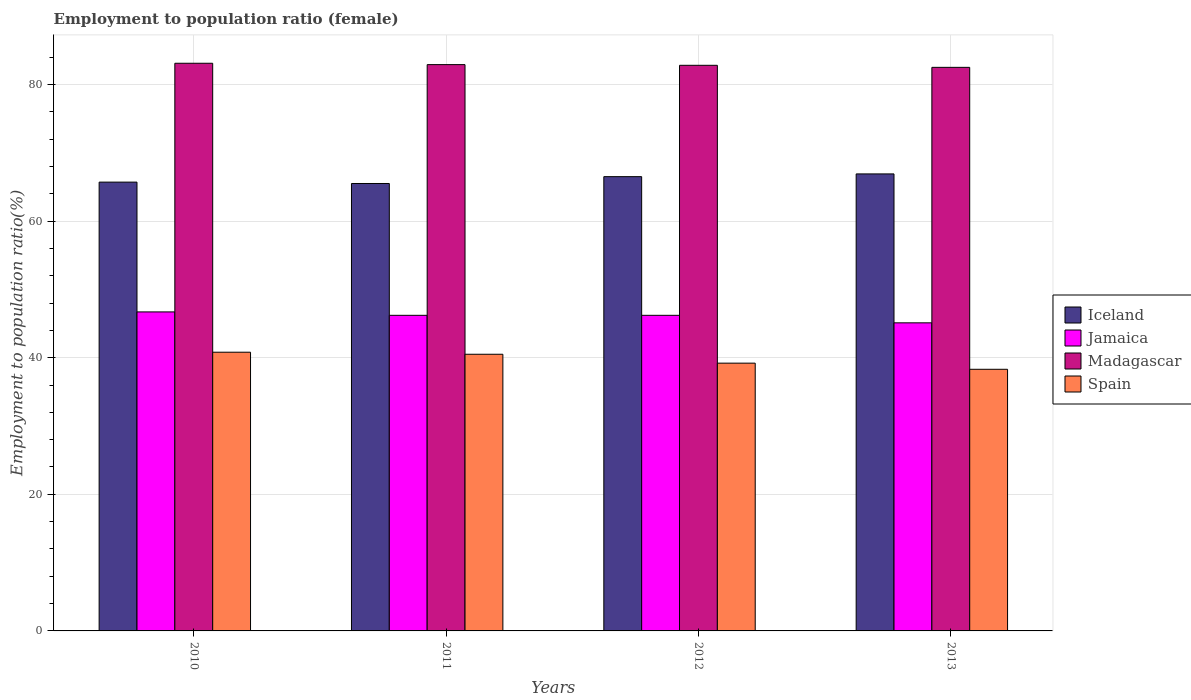In how many cases, is the number of bars for a given year not equal to the number of legend labels?
Give a very brief answer. 0. What is the employment to population ratio in Iceland in 2010?
Keep it short and to the point. 65.7. Across all years, what is the maximum employment to population ratio in Spain?
Your answer should be very brief. 40.8. Across all years, what is the minimum employment to population ratio in Spain?
Provide a succinct answer. 38.3. In which year was the employment to population ratio in Iceland minimum?
Your response must be concise. 2011. What is the total employment to population ratio in Iceland in the graph?
Provide a succinct answer. 264.6. What is the difference between the employment to population ratio in Iceland in 2012 and that in 2013?
Give a very brief answer. -0.4. What is the difference between the employment to population ratio in Iceland in 2011 and the employment to population ratio in Jamaica in 2013?
Provide a short and direct response. 20.4. What is the average employment to population ratio in Madagascar per year?
Your answer should be very brief. 82.83. In the year 2012, what is the difference between the employment to population ratio in Jamaica and employment to population ratio in Iceland?
Your answer should be compact. -20.3. In how many years, is the employment to population ratio in Jamaica greater than 16 %?
Offer a very short reply. 4. What is the ratio of the employment to population ratio in Madagascar in 2010 to that in 2013?
Offer a very short reply. 1.01. What is the difference between the highest and the second highest employment to population ratio in Spain?
Offer a very short reply. 0.3. What is the difference between the highest and the lowest employment to population ratio in Madagascar?
Make the answer very short. 0.6. In how many years, is the employment to population ratio in Spain greater than the average employment to population ratio in Spain taken over all years?
Keep it short and to the point. 2. Is it the case that in every year, the sum of the employment to population ratio in Madagascar and employment to population ratio in Spain is greater than the sum of employment to population ratio in Iceland and employment to population ratio in Jamaica?
Offer a terse response. No. What does the 2nd bar from the left in 2012 represents?
Provide a succinct answer. Jamaica. What does the 4th bar from the right in 2012 represents?
Provide a succinct answer. Iceland. Is it the case that in every year, the sum of the employment to population ratio in Madagascar and employment to population ratio in Jamaica is greater than the employment to population ratio in Spain?
Provide a short and direct response. Yes. Are all the bars in the graph horizontal?
Offer a terse response. No. How many years are there in the graph?
Your answer should be compact. 4. Are the values on the major ticks of Y-axis written in scientific E-notation?
Keep it short and to the point. No. Does the graph contain any zero values?
Your response must be concise. No. How many legend labels are there?
Make the answer very short. 4. What is the title of the graph?
Offer a very short reply. Employment to population ratio (female). Does "Venezuela" appear as one of the legend labels in the graph?
Provide a short and direct response. No. What is the label or title of the X-axis?
Offer a terse response. Years. What is the label or title of the Y-axis?
Keep it short and to the point. Employment to population ratio(%). What is the Employment to population ratio(%) of Iceland in 2010?
Provide a succinct answer. 65.7. What is the Employment to population ratio(%) of Jamaica in 2010?
Keep it short and to the point. 46.7. What is the Employment to population ratio(%) in Madagascar in 2010?
Provide a succinct answer. 83.1. What is the Employment to population ratio(%) in Spain in 2010?
Your answer should be very brief. 40.8. What is the Employment to population ratio(%) of Iceland in 2011?
Offer a very short reply. 65.5. What is the Employment to population ratio(%) of Jamaica in 2011?
Your response must be concise. 46.2. What is the Employment to population ratio(%) in Madagascar in 2011?
Make the answer very short. 82.9. What is the Employment to population ratio(%) of Spain in 2011?
Provide a short and direct response. 40.5. What is the Employment to population ratio(%) of Iceland in 2012?
Provide a short and direct response. 66.5. What is the Employment to population ratio(%) in Jamaica in 2012?
Provide a succinct answer. 46.2. What is the Employment to population ratio(%) in Madagascar in 2012?
Your answer should be very brief. 82.8. What is the Employment to population ratio(%) in Spain in 2012?
Keep it short and to the point. 39.2. What is the Employment to population ratio(%) of Iceland in 2013?
Your answer should be compact. 66.9. What is the Employment to population ratio(%) in Jamaica in 2013?
Offer a terse response. 45.1. What is the Employment to population ratio(%) of Madagascar in 2013?
Provide a succinct answer. 82.5. What is the Employment to population ratio(%) of Spain in 2013?
Offer a very short reply. 38.3. Across all years, what is the maximum Employment to population ratio(%) in Iceland?
Offer a very short reply. 66.9. Across all years, what is the maximum Employment to population ratio(%) in Jamaica?
Offer a terse response. 46.7. Across all years, what is the maximum Employment to population ratio(%) of Madagascar?
Your answer should be compact. 83.1. Across all years, what is the maximum Employment to population ratio(%) in Spain?
Your answer should be compact. 40.8. Across all years, what is the minimum Employment to population ratio(%) of Iceland?
Offer a terse response. 65.5. Across all years, what is the minimum Employment to population ratio(%) in Jamaica?
Your response must be concise. 45.1. Across all years, what is the minimum Employment to population ratio(%) in Madagascar?
Your response must be concise. 82.5. Across all years, what is the minimum Employment to population ratio(%) of Spain?
Ensure brevity in your answer.  38.3. What is the total Employment to population ratio(%) of Iceland in the graph?
Provide a succinct answer. 264.6. What is the total Employment to population ratio(%) of Jamaica in the graph?
Provide a short and direct response. 184.2. What is the total Employment to population ratio(%) of Madagascar in the graph?
Provide a short and direct response. 331.3. What is the total Employment to population ratio(%) in Spain in the graph?
Provide a short and direct response. 158.8. What is the difference between the Employment to population ratio(%) in Iceland in 2010 and that in 2011?
Provide a succinct answer. 0.2. What is the difference between the Employment to population ratio(%) of Madagascar in 2010 and that in 2011?
Provide a short and direct response. 0.2. What is the difference between the Employment to population ratio(%) in Spain in 2010 and that in 2011?
Ensure brevity in your answer.  0.3. What is the difference between the Employment to population ratio(%) in Jamaica in 2010 and that in 2012?
Your answer should be compact. 0.5. What is the difference between the Employment to population ratio(%) in Madagascar in 2010 and that in 2012?
Your answer should be very brief. 0.3. What is the difference between the Employment to population ratio(%) of Iceland in 2010 and that in 2013?
Ensure brevity in your answer.  -1.2. What is the difference between the Employment to population ratio(%) of Jamaica in 2010 and that in 2013?
Provide a short and direct response. 1.6. What is the difference between the Employment to population ratio(%) of Madagascar in 2010 and that in 2013?
Provide a succinct answer. 0.6. What is the difference between the Employment to population ratio(%) of Jamaica in 2011 and that in 2012?
Offer a very short reply. 0. What is the difference between the Employment to population ratio(%) of Spain in 2011 and that in 2012?
Make the answer very short. 1.3. What is the difference between the Employment to population ratio(%) in Jamaica in 2012 and that in 2013?
Your answer should be very brief. 1.1. What is the difference between the Employment to population ratio(%) of Spain in 2012 and that in 2013?
Give a very brief answer. 0.9. What is the difference between the Employment to population ratio(%) in Iceland in 2010 and the Employment to population ratio(%) in Jamaica in 2011?
Offer a terse response. 19.5. What is the difference between the Employment to population ratio(%) in Iceland in 2010 and the Employment to population ratio(%) in Madagascar in 2011?
Offer a terse response. -17.2. What is the difference between the Employment to population ratio(%) of Iceland in 2010 and the Employment to population ratio(%) of Spain in 2011?
Make the answer very short. 25.2. What is the difference between the Employment to population ratio(%) of Jamaica in 2010 and the Employment to population ratio(%) of Madagascar in 2011?
Provide a short and direct response. -36.2. What is the difference between the Employment to population ratio(%) in Madagascar in 2010 and the Employment to population ratio(%) in Spain in 2011?
Your answer should be very brief. 42.6. What is the difference between the Employment to population ratio(%) in Iceland in 2010 and the Employment to population ratio(%) in Jamaica in 2012?
Provide a short and direct response. 19.5. What is the difference between the Employment to population ratio(%) of Iceland in 2010 and the Employment to population ratio(%) of Madagascar in 2012?
Your answer should be compact. -17.1. What is the difference between the Employment to population ratio(%) of Jamaica in 2010 and the Employment to population ratio(%) of Madagascar in 2012?
Your answer should be compact. -36.1. What is the difference between the Employment to population ratio(%) of Jamaica in 2010 and the Employment to population ratio(%) of Spain in 2012?
Your answer should be very brief. 7.5. What is the difference between the Employment to population ratio(%) of Madagascar in 2010 and the Employment to population ratio(%) of Spain in 2012?
Provide a succinct answer. 43.9. What is the difference between the Employment to population ratio(%) in Iceland in 2010 and the Employment to population ratio(%) in Jamaica in 2013?
Provide a short and direct response. 20.6. What is the difference between the Employment to population ratio(%) in Iceland in 2010 and the Employment to population ratio(%) in Madagascar in 2013?
Provide a short and direct response. -16.8. What is the difference between the Employment to population ratio(%) of Iceland in 2010 and the Employment to population ratio(%) of Spain in 2013?
Give a very brief answer. 27.4. What is the difference between the Employment to population ratio(%) of Jamaica in 2010 and the Employment to population ratio(%) of Madagascar in 2013?
Keep it short and to the point. -35.8. What is the difference between the Employment to population ratio(%) in Jamaica in 2010 and the Employment to population ratio(%) in Spain in 2013?
Give a very brief answer. 8.4. What is the difference between the Employment to population ratio(%) in Madagascar in 2010 and the Employment to population ratio(%) in Spain in 2013?
Your response must be concise. 44.8. What is the difference between the Employment to population ratio(%) of Iceland in 2011 and the Employment to population ratio(%) of Jamaica in 2012?
Give a very brief answer. 19.3. What is the difference between the Employment to population ratio(%) in Iceland in 2011 and the Employment to population ratio(%) in Madagascar in 2012?
Provide a short and direct response. -17.3. What is the difference between the Employment to population ratio(%) in Iceland in 2011 and the Employment to population ratio(%) in Spain in 2012?
Offer a very short reply. 26.3. What is the difference between the Employment to population ratio(%) in Jamaica in 2011 and the Employment to population ratio(%) in Madagascar in 2012?
Provide a short and direct response. -36.6. What is the difference between the Employment to population ratio(%) of Madagascar in 2011 and the Employment to population ratio(%) of Spain in 2012?
Offer a very short reply. 43.7. What is the difference between the Employment to population ratio(%) in Iceland in 2011 and the Employment to population ratio(%) in Jamaica in 2013?
Offer a very short reply. 20.4. What is the difference between the Employment to population ratio(%) of Iceland in 2011 and the Employment to population ratio(%) of Spain in 2013?
Your answer should be very brief. 27.2. What is the difference between the Employment to population ratio(%) in Jamaica in 2011 and the Employment to population ratio(%) in Madagascar in 2013?
Keep it short and to the point. -36.3. What is the difference between the Employment to population ratio(%) in Madagascar in 2011 and the Employment to population ratio(%) in Spain in 2013?
Your response must be concise. 44.6. What is the difference between the Employment to population ratio(%) of Iceland in 2012 and the Employment to population ratio(%) of Jamaica in 2013?
Offer a terse response. 21.4. What is the difference between the Employment to population ratio(%) in Iceland in 2012 and the Employment to population ratio(%) in Spain in 2013?
Provide a succinct answer. 28.2. What is the difference between the Employment to population ratio(%) of Jamaica in 2012 and the Employment to population ratio(%) of Madagascar in 2013?
Offer a terse response. -36.3. What is the difference between the Employment to population ratio(%) of Madagascar in 2012 and the Employment to population ratio(%) of Spain in 2013?
Make the answer very short. 44.5. What is the average Employment to population ratio(%) in Iceland per year?
Provide a succinct answer. 66.15. What is the average Employment to population ratio(%) of Jamaica per year?
Offer a very short reply. 46.05. What is the average Employment to population ratio(%) in Madagascar per year?
Offer a terse response. 82.83. What is the average Employment to population ratio(%) of Spain per year?
Your answer should be very brief. 39.7. In the year 2010, what is the difference between the Employment to population ratio(%) of Iceland and Employment to population ratio(%) of Madagascar?
Provide a short and direct response. -17.4. In the year 2010, what is the difference between the Employment to population ratio(%) in Iceland and Employment to population ratio(%) in Spain?
Give a very brief answer. 24.9. In the year 2010, what is the difference between the Employment to population ratio(%) of Jamaica and Employment to population ratio(%) of Madagascar?
Make the answer very short. -36.4. In the year 2010, what is the difference between the Employment to population ratio(%) of Madagascar and Employment to population ratio(%) of Spain?
Keep it short and to the point. 42.3. In the year 2011, what is the difference between the Employment to population ratio(%) of Iceland and Employment to population ratio(%) of Jamaica?
Your response must be concise. 19.3. In the year 2011, what is the difference between the Employment to population ratio(%) in Iceland and Employment to population ratio(%) in Madagascar?
Provide a short and direct response. -17.4. In the year 2011, what is the difference between the Employment to population ratio(%) in Jamaica and Employment to population ratio(%) in Madagascar?
Offer a very short reply. -36.7. In the year 2011, what is the difference between the Employment to population ratio(%) of Jamaica and Employment to population ratio(%) of Spain?
Make the answer very short. 5.7. In the year 2011, what is the difference between the Employment to population ratio(%) of Madagascar and Employment to population ratio(%) of Spain?
Give a very brief answer. 42.4. In the year 2012, what is the difference between the Employment to population ratio(%) in Iceland and Employment to population ratio(%) in Jamaica?
Give a very brief answer. 20.3. In the year 2012, what is the difference between the Employment to population ratio(%) in Iceland and Employment to population ratio(%) in Madagascar?
Give a very brief answer. -16.3. In the year 2012, what is the difference between the Employment to population ratio(%) in Iceland and Employment to population ratio(%) in Spain?
Ensure brevity in your answer.  27.3. In the year 2012, what is the difference between the Employment to population ratio(%) of Jamaica and Employment to population ratio(%) of Madagascar?
Provide a short and direct response. -36.6. In the year 2012, what is the difference between the Employment to population ratio(%) in Madagascar and Employment to population ratio(%) in Spain?
Provide a short and direct response. 43.6. In the year 2013, what is the difference between the Employment to population ratio(%) of Iceland and Employment to population ratio(%) of Jamaica?
Your answer should be very brief. 21.8. In the year 2013, what is the difference between the Employment to population ratio(%) of Iceland and Employment to population ratio(%) of Madagascar?
Provide a succinct answer. -15.6. In the year 2013, what is the difference between the Employment to population ratio(%) of Iceland and Employment to population ratio(%) of Spain?
Offer a very short reply. 28.6. In the year 2013, what is the difference between the Employment to population ratio(%) in Jamaica and Employment to population ratio(%) in Madagascar?
Keep it short and to the point. -37.4. In the year 2013, what is the difference between the Employment to population ratio(%) of Madagascar and Employment to population ratio(%) of Spain?
Give a very brief answer. 44.2. What is the ratio of the Employment to population ratio(%) in Jamaica in 2010 to that in 2011?
Offer a terse response. 1.01. What is the ratio of the Employment to population ratio(%) in Spain in 2010 to that in 2011?
Keep it short and to the point. 1.01. What is the ratio of the Employment to population ratio(%) of Jamaica in 2010 to that in 2012?
Your response must be concise. 1.01. What is the ratio of the Employment to population ratio(%) in Madagascar in 2010 to that in 2012?
Your response must be concise. 1. What is the ratio of the Employment to population ratio(%) in Spain in 2010 to that in 2012?
Give a very brief answer. 1.04. What is the ratio of the Employment to population ratio(%) in Iceland in 2010 to that in 2013?
Provide a short and direct response. 0.98. What is the ratio of the Employment to population ratio(%) in Jamaica in 2010 to that in 2013?
Keep it short and to the point. 1.04. What is the ratio of the Employment to population ratio(%) of Madagascar in 2010 to that in 2013?
Offer a terse response. 1.01. What is the ratio of the Employment to population ratio(%) in Spain in 2010 to that in 2013?
Provide a succinct answer. 1.07. What is the ratio of the Employment to population ratio(%) in Jamaica in 2011 to that in 2012?
Keep it short and to the point. 1. What is the ratio of the Employment to population ratio(%) in Spain in 2011 to that in 2012?
Ensure brevity in your answer.  1.03. What is the ratio of the Employment to population ratio(%) in Iceland in 2011 to that in 2013?
Provide a short and direct response. 0.98. What is the ratio of the Employment to population ratio(%) in Jamaica in 2011 to that in 2013?
Keep it short and to the point. 1.02. What is the ratio of the Employment to population ratio(%) of Spain in 2011 to that in 2013?
Keep it short and to the point. 1.06. What is the ratio of the Employment to population ratio(%) in Iceland in 2012 to that in 2013?
Offer a very short reply. 0.99. What is the ratio of the Employment to population ratio(%) in Jamaica in 2012 to that in 2013?
Your response must be concise. 1.02. What is the ratio of the Employment to population ratio(%) in Spain in 2012 to that in 2013?
Offer a terse response. 1.02. What is the difference between the highest and the second highest Employment to population ratio(%) of Madagascar?
Offer a terse response. 0.2. What is the difference between the highest and the lowest Employment to population ratio(%) of Madagascar?
Offer a very short reply. 0.6. What is the difference between the highest and the lowest Employment to population ratio(%) of Spain?
Give a very brief answer. 2.5. 